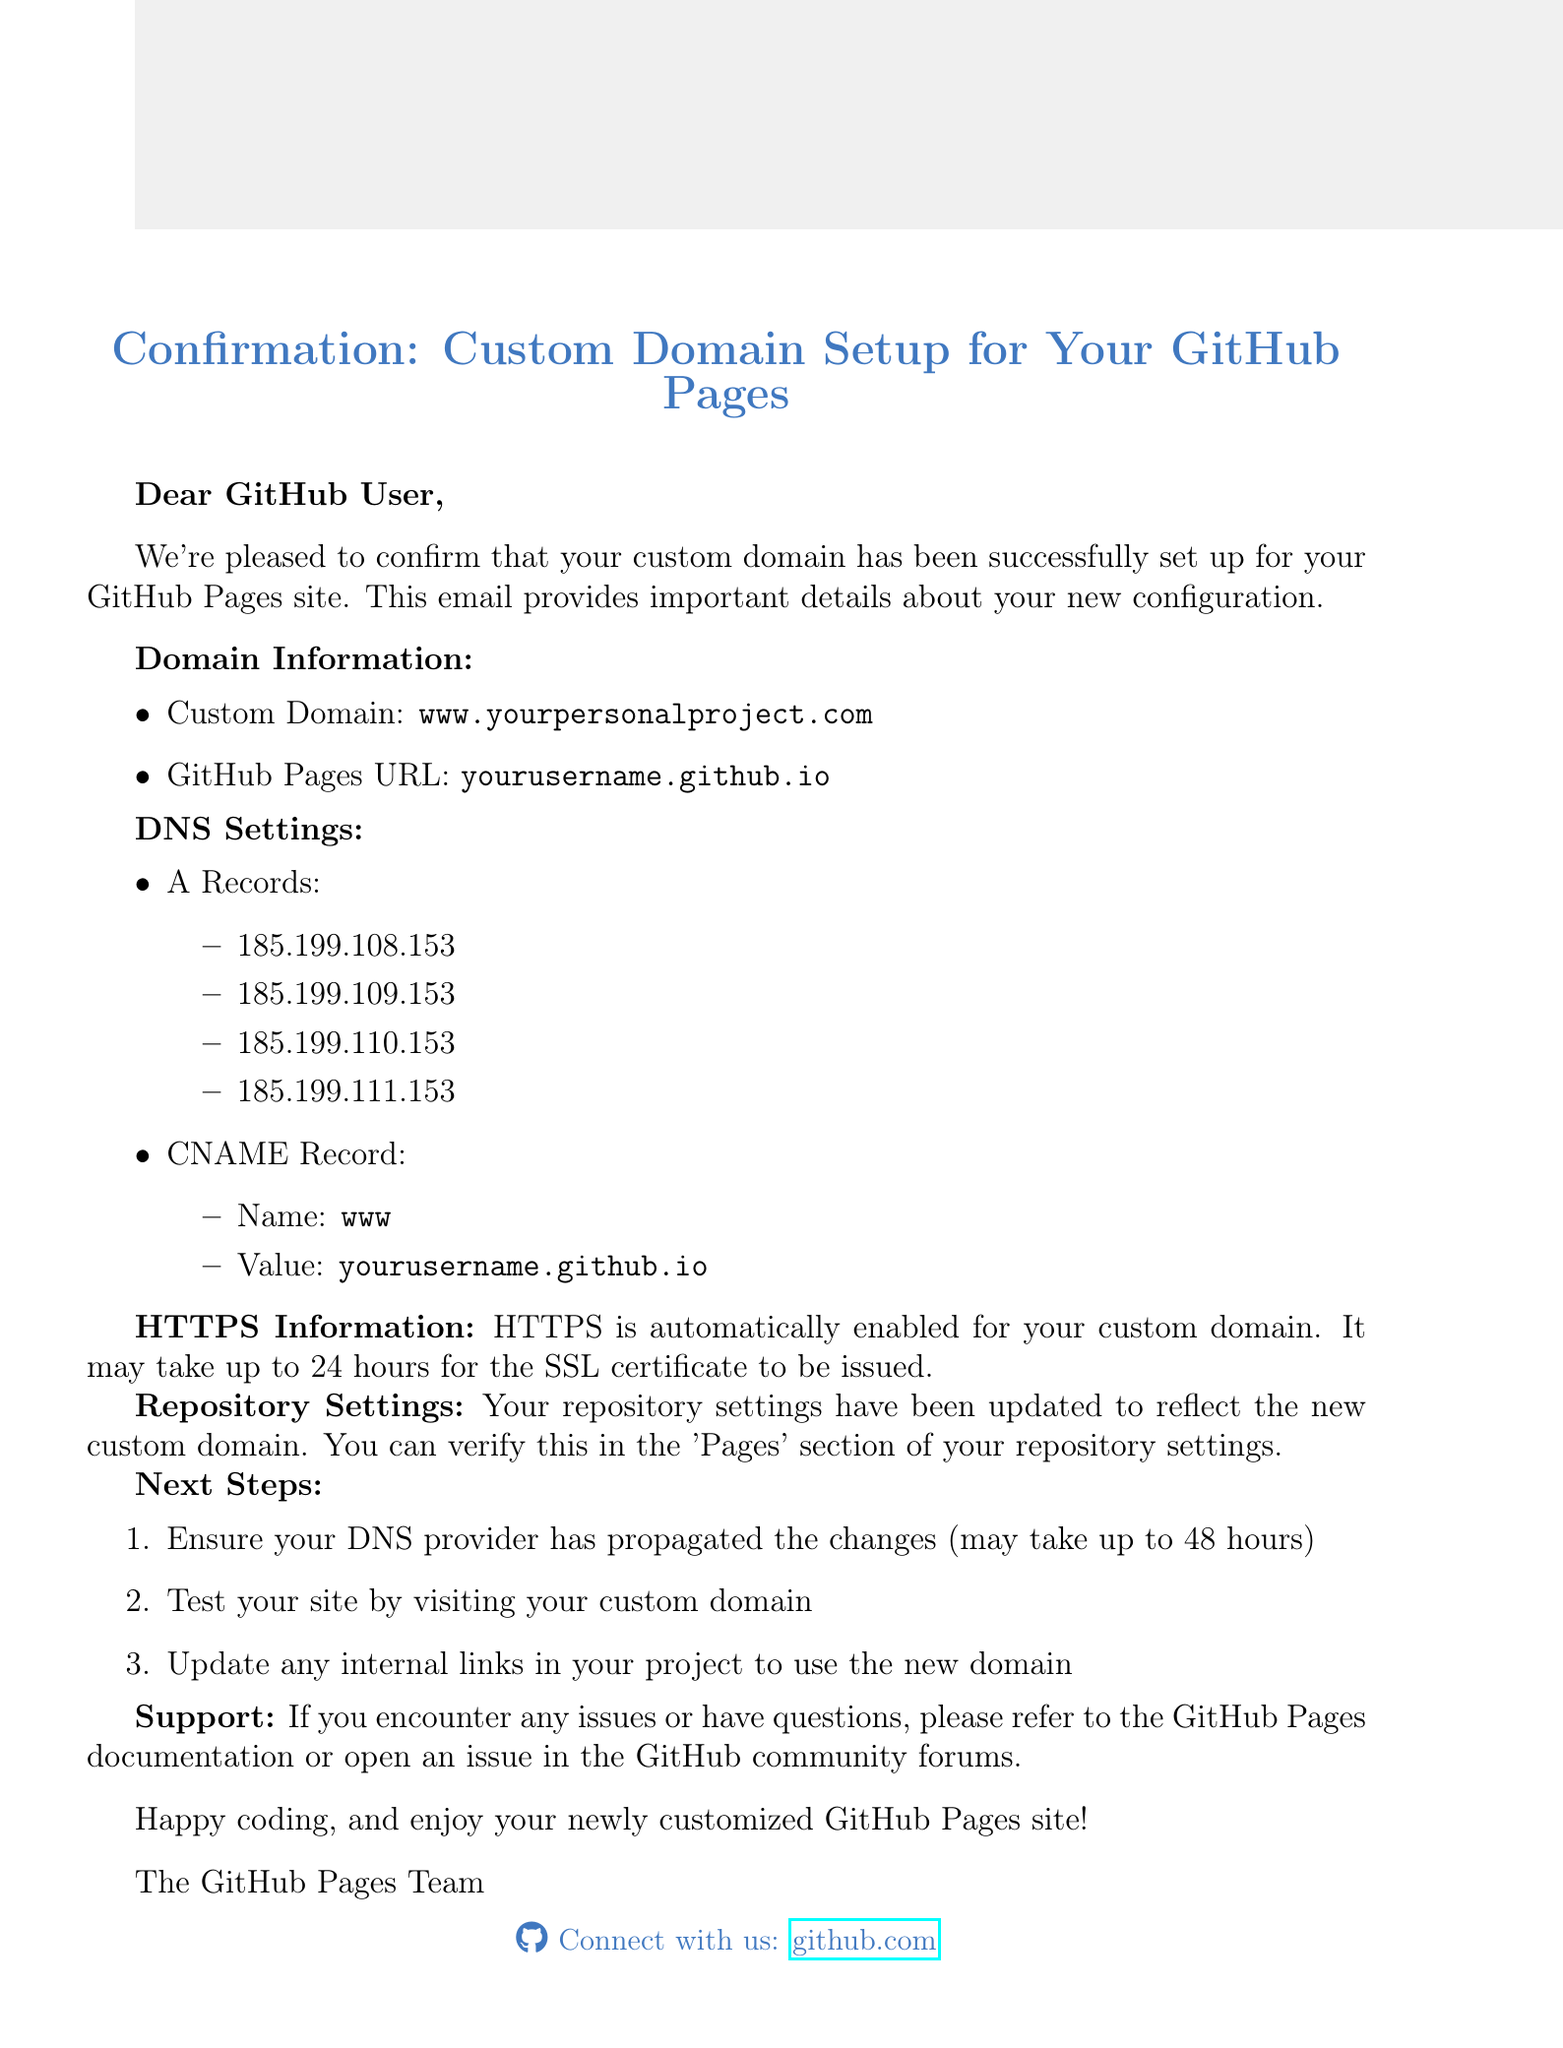What is the custom domain set up for the GitHub Pages? The custom domain is stated explicitly in the document as "www.yourpersonalproject.com."
Answer: www.yourpersonalproject.com What is the GitHub Pages URL associated with your custom domain? The document mentions the GitHub Pages URL as "yourusername.github.io."
Answer: yourusername.github.io How many A Records are provided for the DNS settings? The document lists four A Records under the DNS Settings section.
Answer: 4 What is the name of the CNAME Record listed in the document? The document specifies the CNAME Record name as "www."
Answer: www How long may it take for the SSL certificate to be issued? The document states that it may take up to 24 hours for the SSL certificate to be issued.
Answer: 24 hours What is the first step listed under next steps to verify the custom domain? The document instructs to ensure the DNS provider has propagated the changes.
Answer: Ensure DNS provider has propagated changes What should you do if you encounter issues according to the document? The document advises to refer to GitHub Pages documentation or open an issue in the GitHub community forums.
Answer: Refer to documentation or open an issue Which team signed off the email? The signature in the document indicates that the email is from "The GitHub Pages Team."
Answer: The GitHub Pages Team Is HTTPS enabled for the custom domain? The document confirms that HTTPS is automatically enabled for the custom domain.
Answer: Yes 